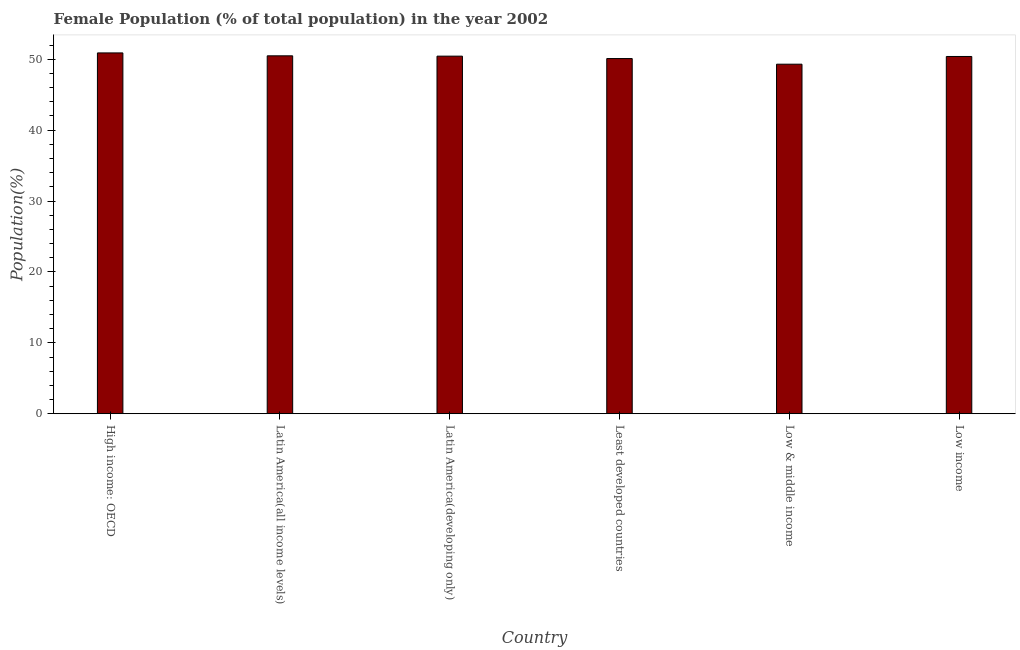What is the title of the graph?
Your response must be concise. Female Population (% of total population) in the year 2002. What is the label or title of the Y-axis?
Your answer should be very brief. Population(%). What is the female population in Least developed countries?
Make the answer very short. 50.09. Across all countries, what is the maximum female population?
Keep it short and to the point. 50.89. Across all countries, what is the minimum female population?
Ensure brevity in your answer.  49.3. In which country was the female population maximum?
Your response must be concise. High income: OECD. In which country was the female population minimum?
Give a very brief answer. Low & middle income. What is the sum of the female population?
Ensure brevity in your answer.  301.58. What is the difference between the female population in High income: OECD and Low & middle income?
Your response must be concise. 1.59. What is the average female population per country?
Your answer should be very brief. 50.26. What is the median female population?
Keep it short and to the point. 50.41. What is the ratio of the female population in Latin America(all income levels) to that in Least developed countries?
Offer a very short reply. 1.01. Is the female population in Latin America(developing only) less than that in Low income?
Make the answer very short. No. What is the difference between the highest and the second highest female population?
Make the answer very short. 0.41. What is the difference between the highest and the lowest female population?
Offer a terse response. 1.59. Are all the bars in the graph horizontal?
Offer a terse response. No. How many countries are there in the graph?
Your answer should be very brief. 6. Are the values on the major ticks of Y-axis written in scientific E-notation?
Provide a short and direct response. No. What is the Population(%) of High income: OECD?
Provide a short and direct response. 50.89. What is the Population(%) of Latin America(all income levels)?
Offer a very short reply. 50.48. What is the Population(%) of Latin America(developing only)?
Keep it short and to the point. 50.43. What is the Population(%) in Least developed countries?
Your answer should be compact. 50.09. What is the Population(%) of Low & middle income?
Your answer should be compact. 49.3. What is the Population(%) of Low income?
Keep it short and to the point. 50.39. What is the difference between the Population(%) in High income: OECD and Latin America(all income levels)?
Your answer should be compact. 0.41. What is the difference between the Population(%) in High income: OECD and Latin America(developing only)?
Make the answer very short. 0.46. What is the difference between the Population(%) in High income: OECD and Least developed countries?
Offer a terse response. 0.79. What is the difference between the Population(%) in High income: OECD and Low & middle income?
Your answer should be compact. 1.59. What is the difference between the Population(%) in High income: OECD and Low income?
Provide a short and direct response. 0.5. What is the difference between the Population(%) in Latin America(all income levels) and Latin America(developing only)?
Your answer should be very brief. 0.05. What is the difference between the Population(%) in Latin America(all income levels) and Least developed countries?
Your answer should be compact. 0.38. What is the difference between the Population(%) in Latin America(all income levels) and Low & middle income?
Keep it short and to the point. 1.18. What is the difference between the Population(%) in Latin America(all income levels) and Low income?
Your response must be concise. 0.09. What is the difference between the Population(%) in Latin America(developing only) and Least developed countries?
Offer a terse response. 0.34. What is the difference between the Population(%) in Latin America(developing only) and Low & middle income?
Provide a short and direct response. 1.13. What is the difference between the Population(%) in Latin America(developing only) and Low income?
Your answer should be very brief. 0.05. What is the difference between the Population(%) in Least developed countries and Low & middle income?
Your response must be concise. 0.8. What is the difference between the Population(%) in Least developed countries and Low income?
Your answer should be compact. -0.29. What is the difference between the Population(%) in Low & middle income and Low income?
Your answer should be very brief. -1.09. What is the ratio of the Population(%) in High income: OECD to that in Latin America(all income levels)?
Your answer should be very brief. 1.01. What is the ratio of the Population(%) in High income: OECD to that in Least developed countries?
Your response must be concise. 1.02. What is the ratio of the Population(%) in High income: OECD to that in Low & middle income?
Your response must be concise. 1.03. What is the ratio of the Population(%) in Latin America(all income levels) to that in Least developed countries?
Keep it short and to the point. 1.01. What is the ratio of the Population(%) in Latin America(all income levels) to that in Low income?
Offer a terse response. 1. What is the ratio of the Population(%) in Latin America(developing only) to that in Least developed countries?
Provide a short and direct response. 1.01. 